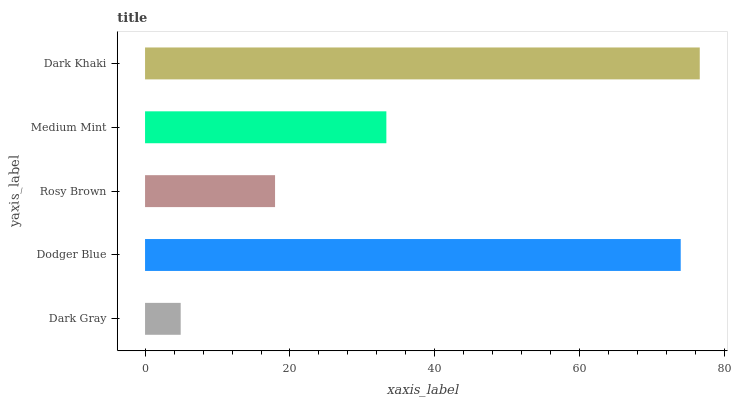Is Dark Gray the minimum?
Answer yes or no. Yes. Is Dark Khaki the maximum?
Answer yes or no. Yes. Is Dodger Blue the minimum?
Answer yes or no. No. Is Dodger Blue the maximum?
Answer yes or no. No. Is Dodger Blue greater than Dark Gray?
Answer yes or no. Yes. Is Dark Gray less than Dodger Blue?
Answer yes or no. Yes. Is Dark Gray greater than Dodger Blue?
Answer yes or no. No. Is Dodger Blue less than Dark Gray?
Answer yes or no. No. Is Medium Mint the high median?
Answer yes or no. Yes. Is Medium Mint the low median?
Answer yes or no. Yes. Is Dark Khaki the high median?
Answer yes or no. No. Is Rosy Brown the low median?
Answer yes or no. No. 